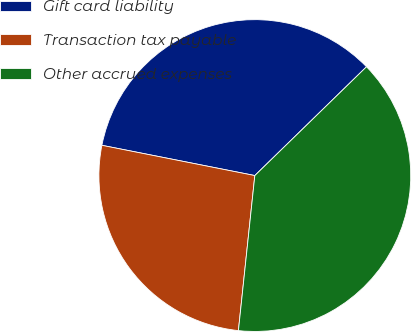Convert chart. <chart><loc_0><loc_0><loc_500><loc_500><pie_chart><fcel>Gift card liability<fcel>Transaction tax payable<fcel>Other accrued expenses<nl><fcel>34.6%<fcel>26.43%<fcel>38.97%<nl></chart> 